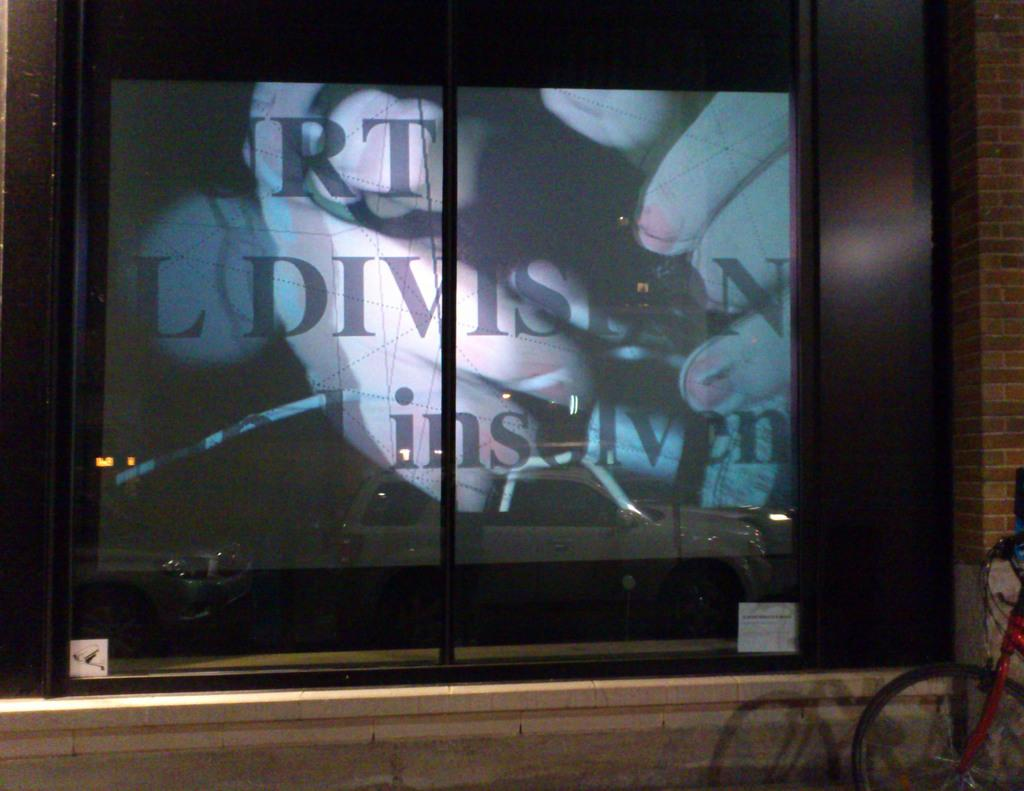Provide a one-sentence caption for the provided image. A window display featuring the word division is visible from the sidewalk. 